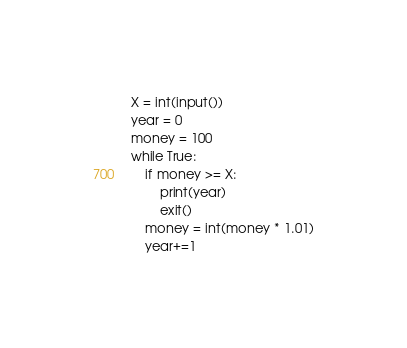Convert code to text. <code><loc_0><loc_0><loc_500><loc_500><_Python_>X = int(input())
year = 0
money = 100
while True:
    if money >= X:
        print(year)
        exit()
    money = int(money * 1.01)
    year+=1

</code> 